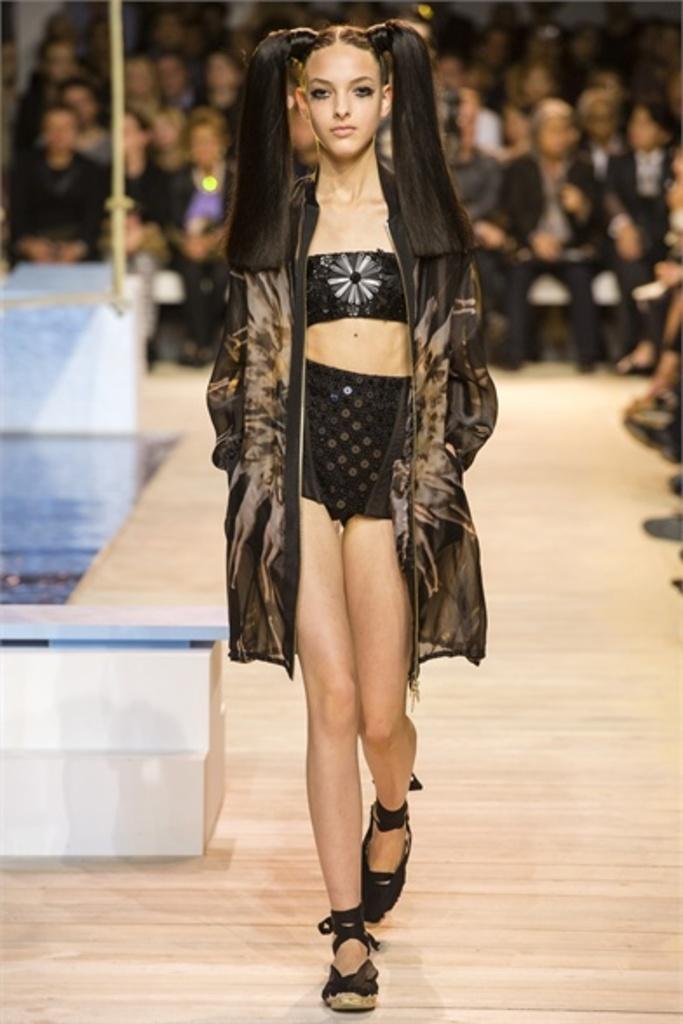Describe this image in one or two sentences. In this image I can see a woman walking on the floor. In the background, I can see some people. 